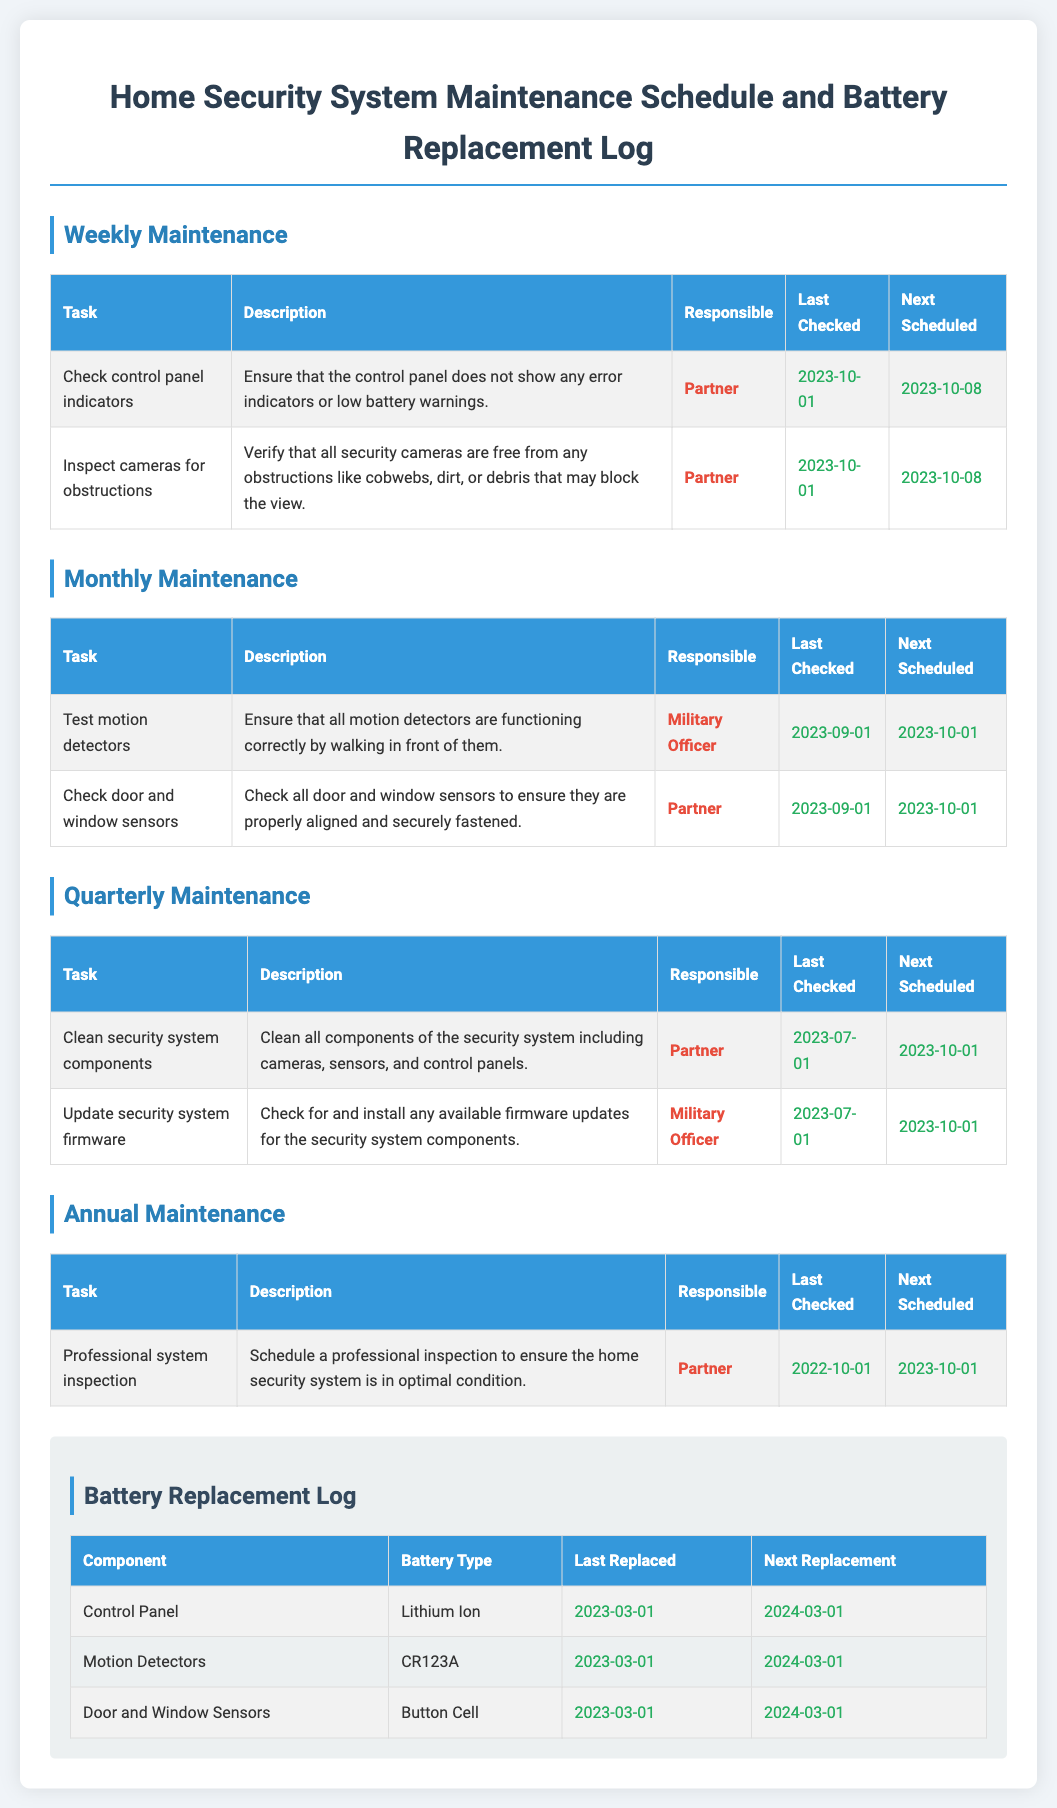what is the date of the last weekly maintenance check? The last weekly maintenance check was conducted on October 1, 2023, according to the schedule.
Answer: 2023-10-01 who is responsible for checking door and window sensors? The task of checking door and window sensors is assigned to the Partner as specified in the monthly maintenance section.
Answer: Partner when is the next scheduled cleaning of security system components? The next scheduled cleaning of security system components is set for October 1, 2023, as noted in the quarterly maintenance section.
Answer: 2023-10-01 what type of battery is used in the Control Panel? The Control Panel uses a Lithium Ion battery type, as stated in the battery replacement log.
Answer: Lithium Ion how often should professional system inspection occur? The professional system inspection is scheduled for annually, which is indicated in the annual maintenance section.
Answer: Annually what was the last date battery was replaced in the motion detectors? The motion detectors' batteries were last replaced on March 1, 2023, according to the battery replacement log.
Answer: 2023-03-01 who is responsible for updating the security system firmware? The Military Officer is responsible for updating the security system firmware as noted in the quarterly maintenance tasks.
Answer: Military Officer what is the next replacement date for door and window sensors' batteries? The next replacement date for door and window sensors' batteries is listed as March 1, 2024, in the battery replacement log.
Answer: 2024-03-01 what task needs to be completed on October 8, 2023? The task of checking control panel indicators and inspecting cameras for obstructions are both due on this date according to the weekly maintenance schedule.
Answer: Check control panel indicators and Inspect cameras for obstructions 